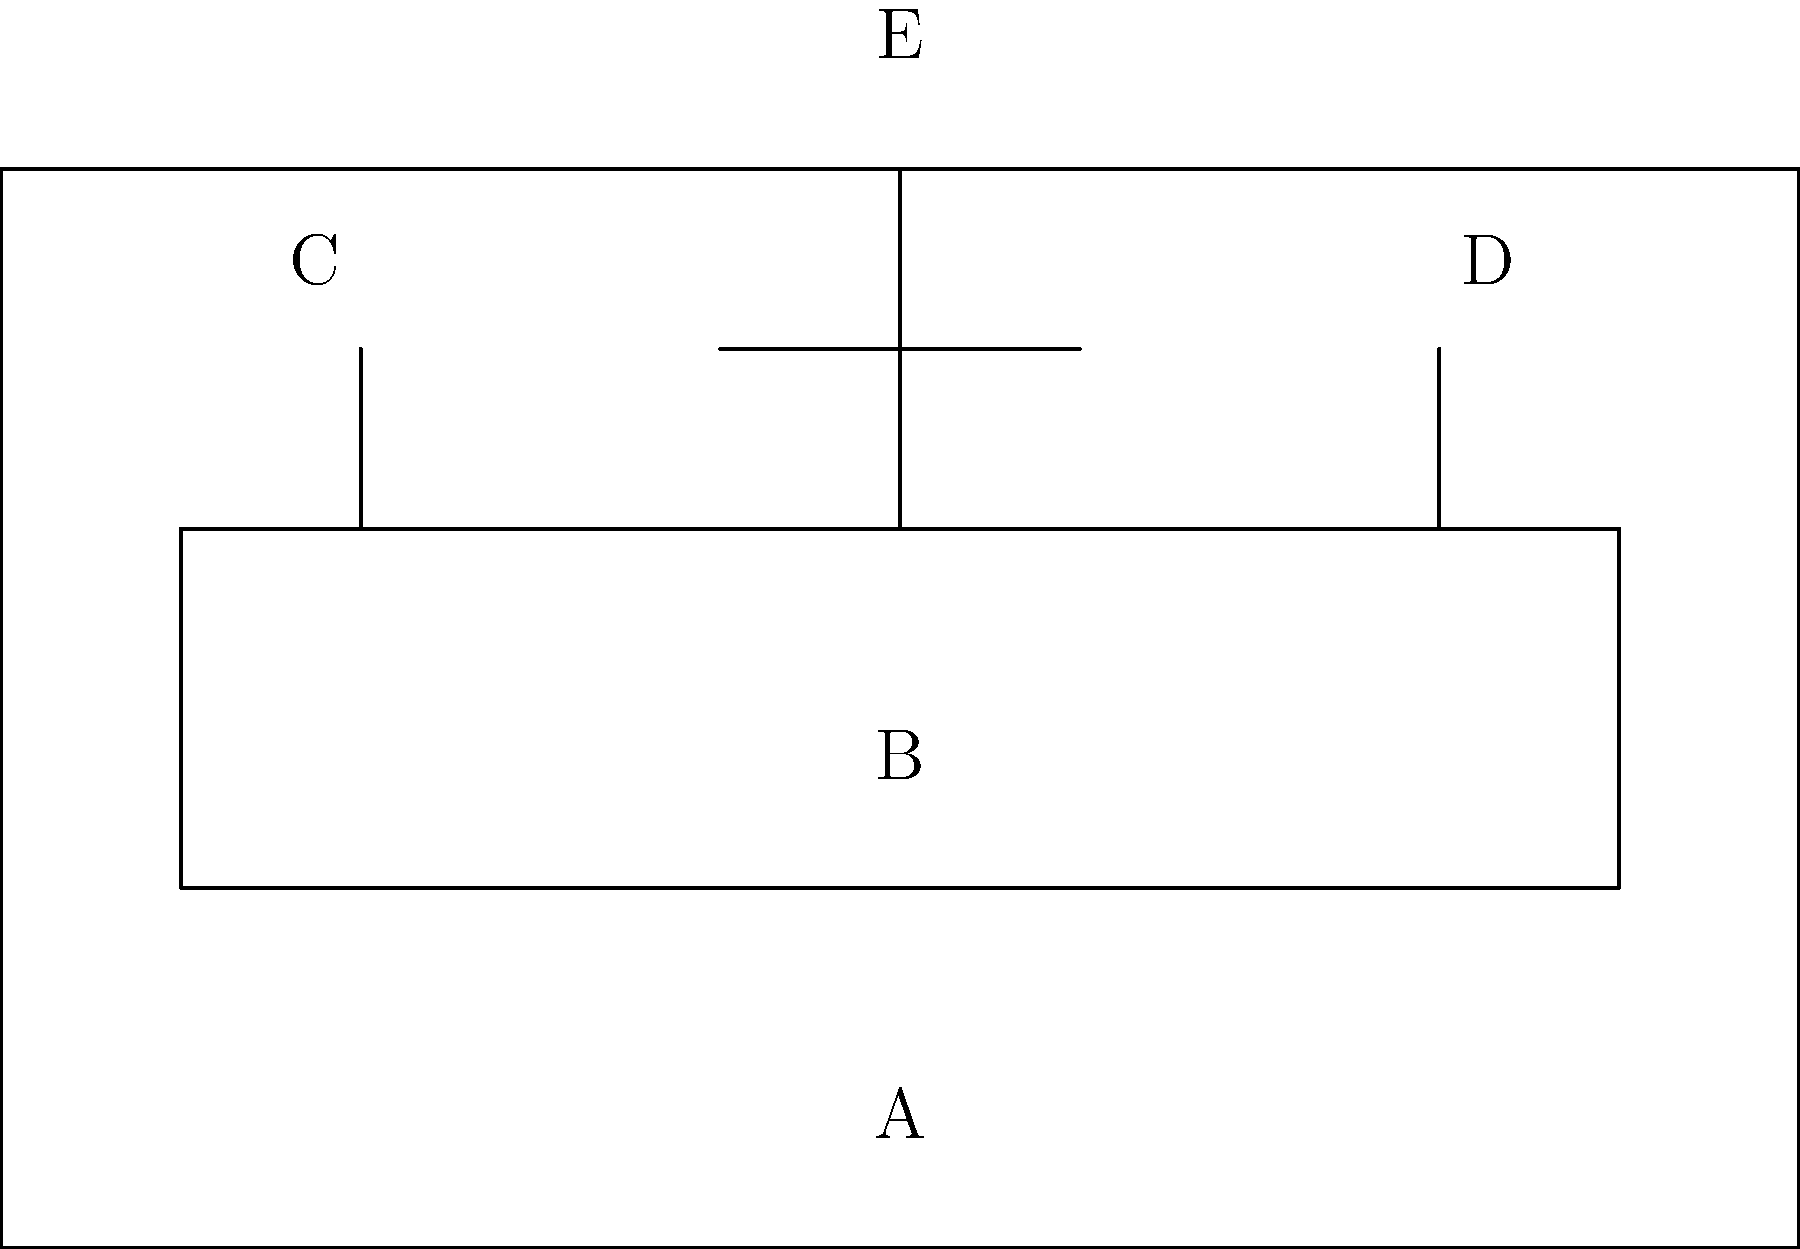Identify the components of the church altar shown in the diagram. What do each of these elements symbolize in Christian worship? The diagram shows a typical church altar with several key components:

1. A: The base or predella - This is the platform on which the altar stands, representing the foundation of faith.

2. B: The altar table or mensa - This is the central structure where the Eucharist is celebrated, symbolizing the table of the Last Supper and Christ's sacrifice.

3. C and D: Candles - These represent the light of Christ and are often placed on either side of the altar. They also symbolize prayer and the presence of God.

4. E: The cross - Placed centrally and prominently, it represents Christ's sacrifice and is the primary symbol of Christian faith.

Each of these elements has deep symbolic meaning in Christian worship:

- The altar as a whole represents Christ himself, often referred to as the "living stone" in Scripture.
- The candles remind worshippers of Christ as the light of the world and call them to be light-bearers.
- The cross is a constant reminder of Christ's death and resurrection, central to Christian belief.

Together, these elements create a sacred space for worship, prayer, and the celebration of the Eucharist, which is at the heart of Christian liturgy.
Answer: A: Predella (foundation of faith), B: Altar table (Christ's sacrifice), C&D: Candles (light of Christ), E: Cross (central Christian symbol) 